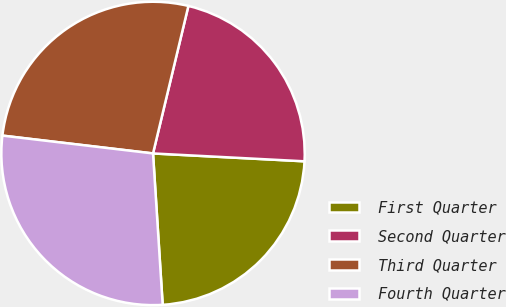Convert chart to OTSL. <chart><loc_0><loc_0><loc_500><loc_500><pie_chart><fcel>First Quarter<fcel>Second Quarter<fcel>Third Quarter<fcel>Fourth Quarter<nl><fcel>23.16%<fcel>22.08%<fcel>26.87%<fcel>27.89%<nl></chart> 